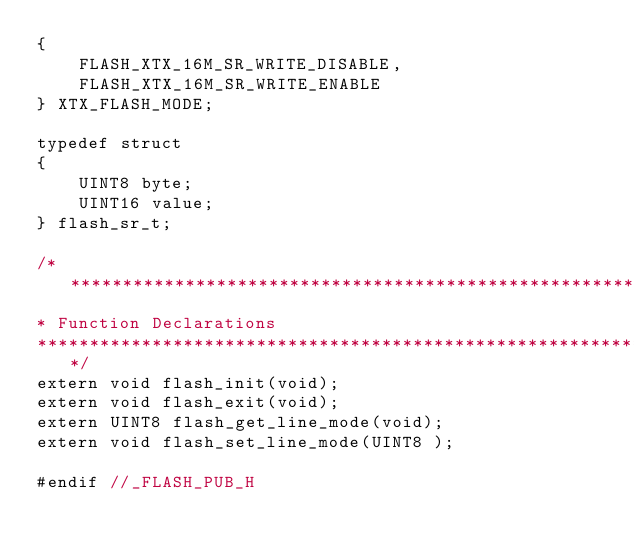<code> <loc_0><loc_0><loc_500><loc_500><_C_>{
    FLASH_XTX_16M_SR_WRITE_DISABLE,
    FLASH_XTX_16M_SR_WRITE_ENABLE
} XTX_FLASH_MODE;

typedef struct
{
    UINT8 byte;
    UINT16 value;
} flash_sr_t;

/*******************************************************************************
* Function Declarations
*******************************************************************************/
extern void flash_init(void);
extern void flash_exit(void);
extern UINT8 flash_get_line_mode(void);
extern void flash_set_line_mode(UINT8 );

#endif //_FLASH_PUB_H
</code> 